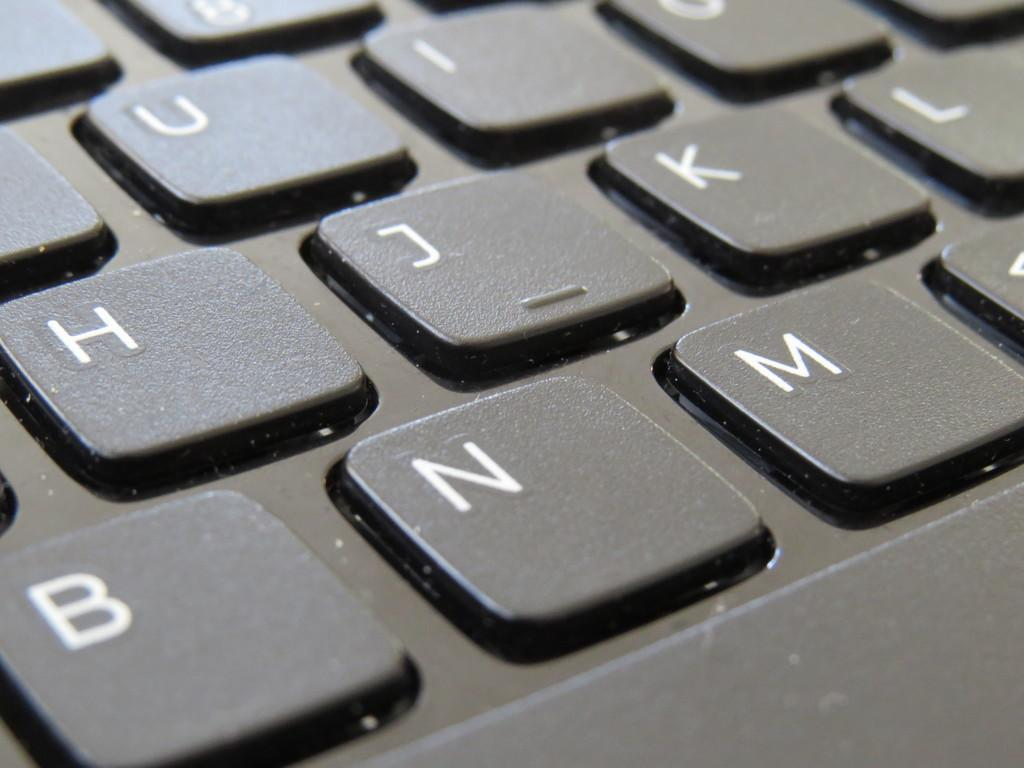<image>
Give a short and clear explanation of the subsequent image. A keyboard with a focus on the BNM letters. 